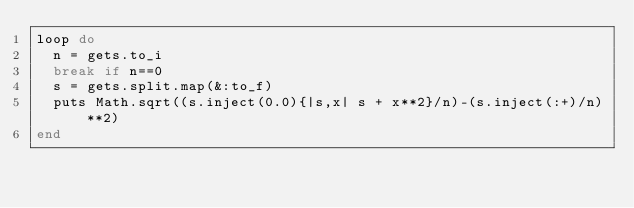<code> <loc_0><loc_0><loc_500><loc_500><_Ruby_>loop do
  n = gets.to_i
  break if n==0
  s = gets.split.map(&:to_f)
  puts Math.sqrt((s.inject(0.0){|s,x| s + x**2}/n)-(s.inject(:+)/n)**2)
end</code> 